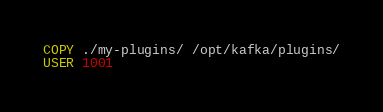Convert code to text. <code><loc_0><loc_0><loc_500><loc_500><_Dockerfile_>COPY ./my-plugins/ /opt/kafka/plugins/
USER 1001
</code> 